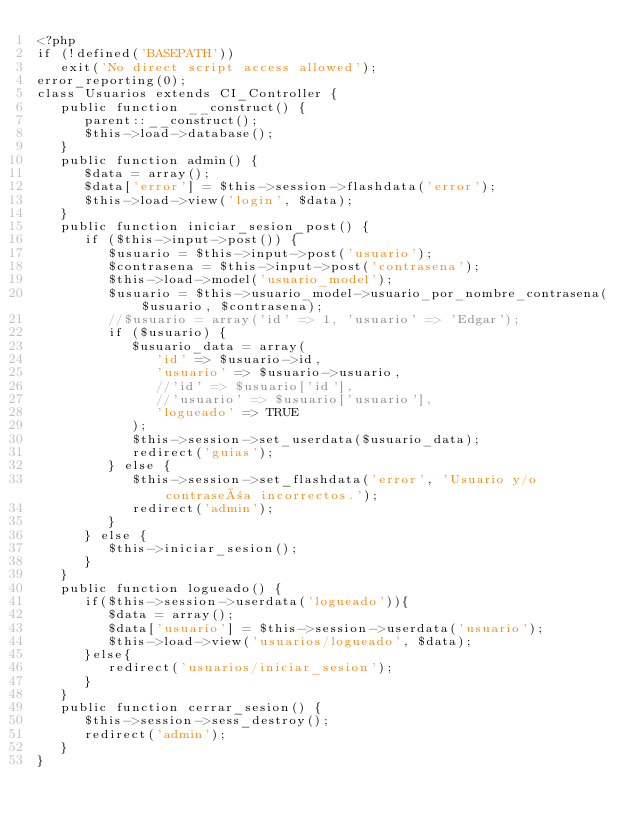Convert code to text. <code><loc_0><loc_0><loc_500><loc_500><_PHP_><?php
if (!defined('BASEPATH'))
   exit('No direct script access allowed');
error_reporting(0);
class Usuarios extends CI_Controller {
   public function __construct() {
      parent::__construct();
      $this->load->database();
   }
   public function admin() {
      $data = array();
      $data['error'] = $this->session->flashdata('error');
      $this->load->view('login', $data);
   }
   public function iniciar_sesion_post() {
      if ($this->input->post()) {
         $usuario = $this->input->post('usuario');
         $contrasena = $this->input->post('contrasena');
         $this->load->model('usuario_model');
         $usuario = $this->usuario_model->usuario_por_nombre_contrasena($usuario, $contrasena);
         //$usuario = array('id' => 1, 'usuario' => 'Edgar');
         if ($usuario) {
            $usuario_data = array(
               'id' => $usuario->id,
               'usuario' => $usuario->usuario,
               //'id' => $usuario['id'],
               //'usuario' => $usuario['usuario'],
               'logueado' => TRUE
            );
            $this->session->set_userdata($usuario_data);
            redirect('guias');
         } else {
            $this->session->set_flashdata('error', 'Usuario y/o contraseña incorrectos.'); 
            redirect('admin');
         }
      } else {
         $this->iniciar_sesion();
      }
   }
   public function logueado() {
      if($this->session->userdata('logueado')){
         $data = array();
         $data['usuario'] = $this->session->userdata('usuario');
         $this->load->view('usuarios/logueado', $data);
      }else{
         redirect('usuarios/iniciar_sesion');
      }
   }
   public function cerrar_sesion() {
      $this->session->sess_destroy();
      redirect('admin');
   }
}</code> 